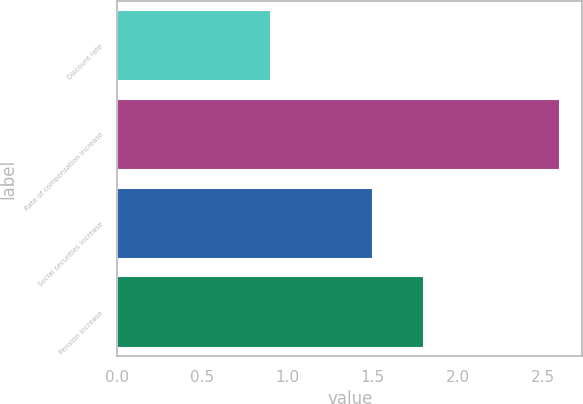Convert chart. <chart><loc_0><loc_0><loc_500><loc_500><bar_chart><fcel>Discount rate<fcel>Rate of compensation increase<fcel>Social securities increase<fcel>Pension increase<nl><fcel>0.9<fcel>2.6<fcel>1.5<fcel>1.8<nl></chart> 